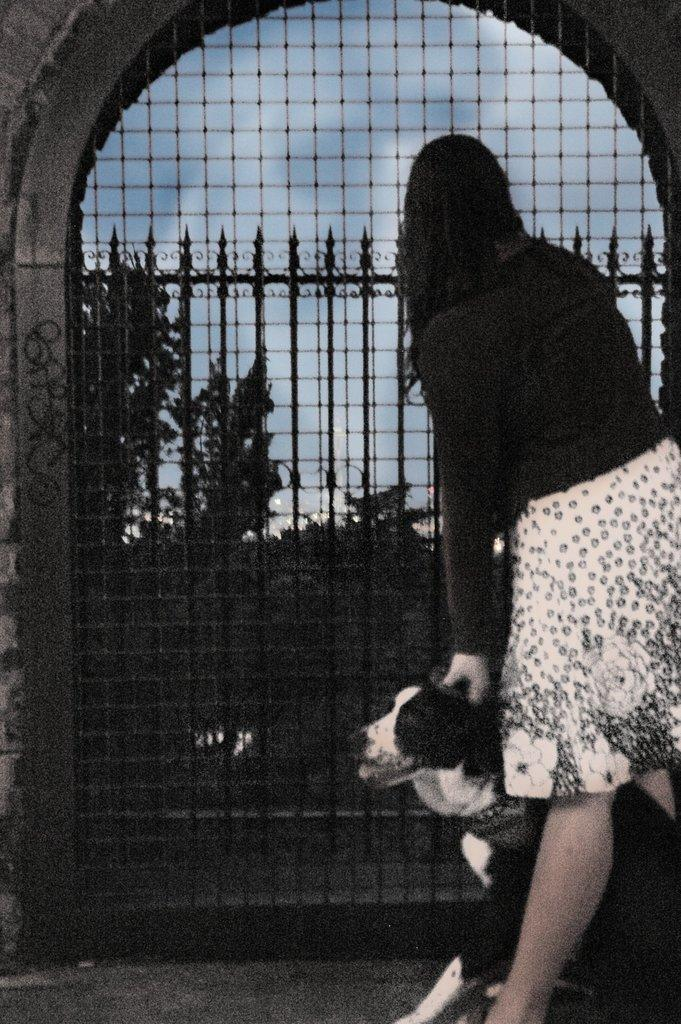Who is present in the image? There is a woman in the image. What is the woman doing in the image? The woman is standing and touching a dog. What can be seen in the background of the image? There is a sky, trees, a wall, an arch, and a black color grill gate visible in the background of the image. What type of lock is visible on the edge of the development in the image? There is no lock or development present in the image. 